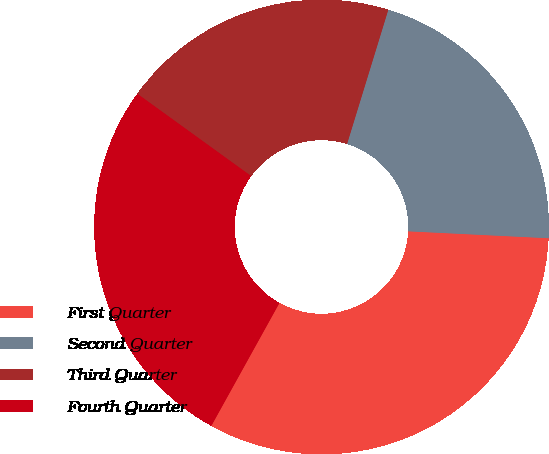Convert chart. <chart><loc_0><loc_0><loc_500><loc_500><pie_chart><fcel>First Quarter<fcel>Second Quarter<fcel>Third Quarter<fcel>Fourth Quarter<nl><fcel>32.27%<fcel>21.04%<fcel>19.78%<fcel>26.91%<nl></chart> 